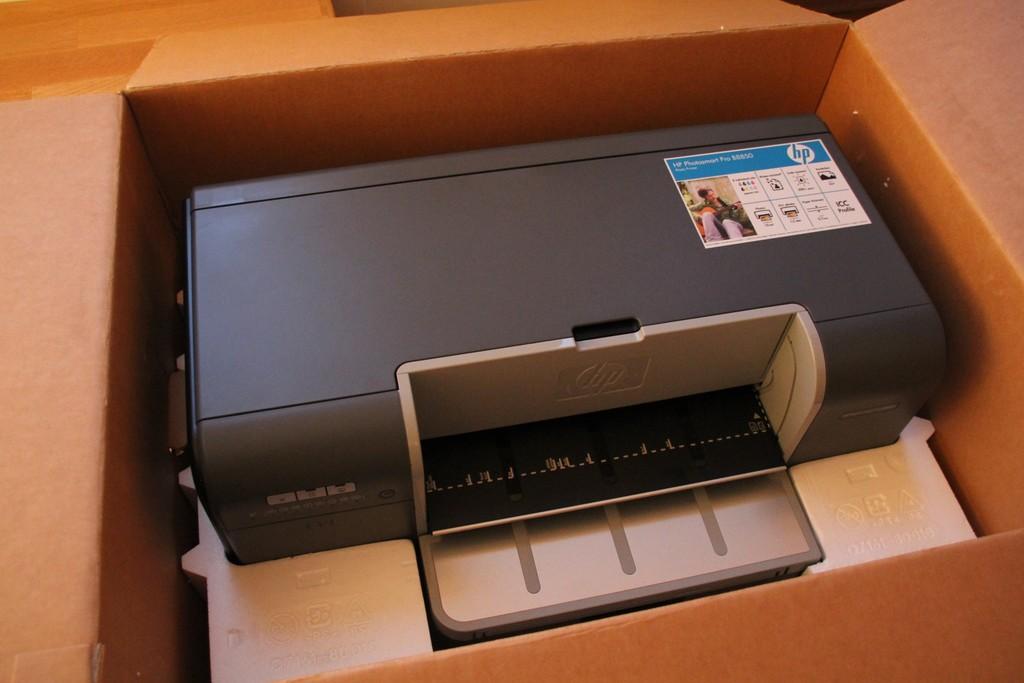Who made the printer?
Provide a short and direct response. Hp. 